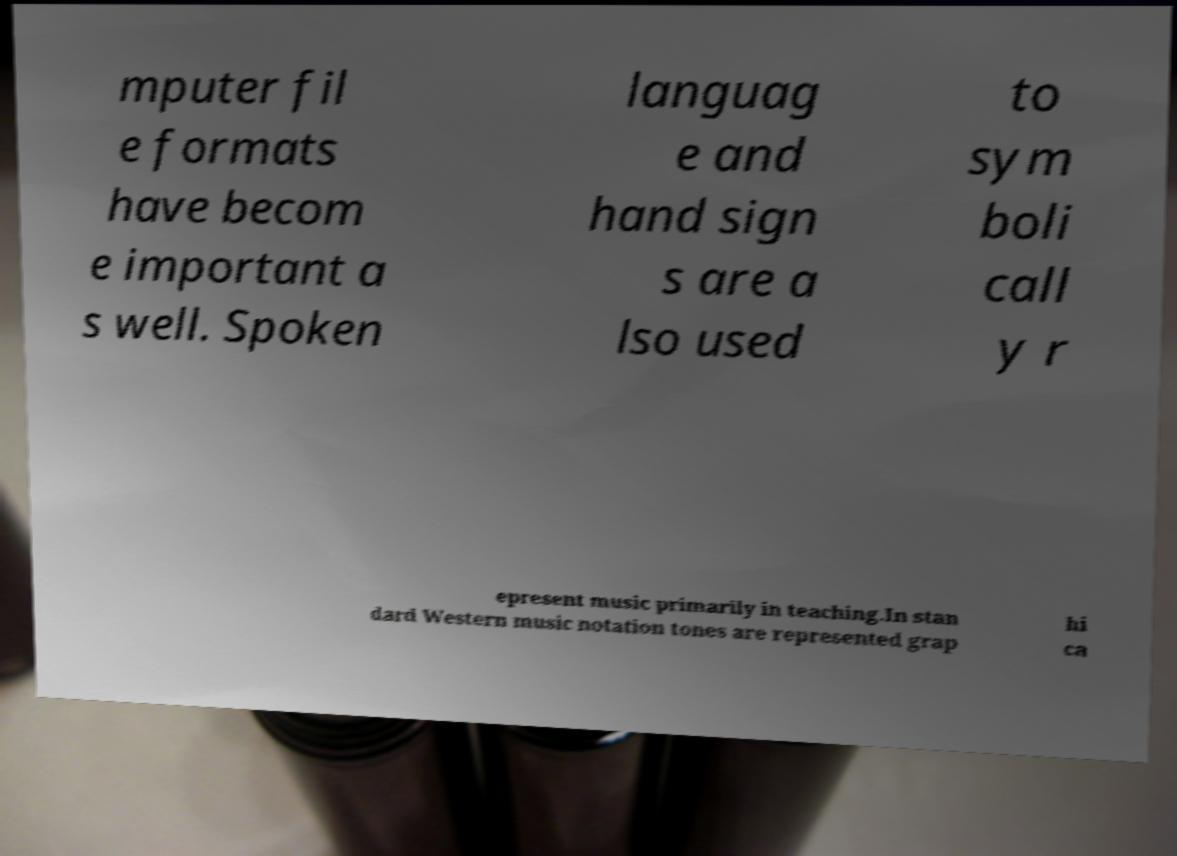Please read and relay the text visible in this image. What does it say? mputer fil e formats have becom e important a s well. Spoken languag e and hand sign s are a lso used to sym boli call y r epresent music primarily in teaching.In stan dard Western music notation tones are represented grap hi ca 